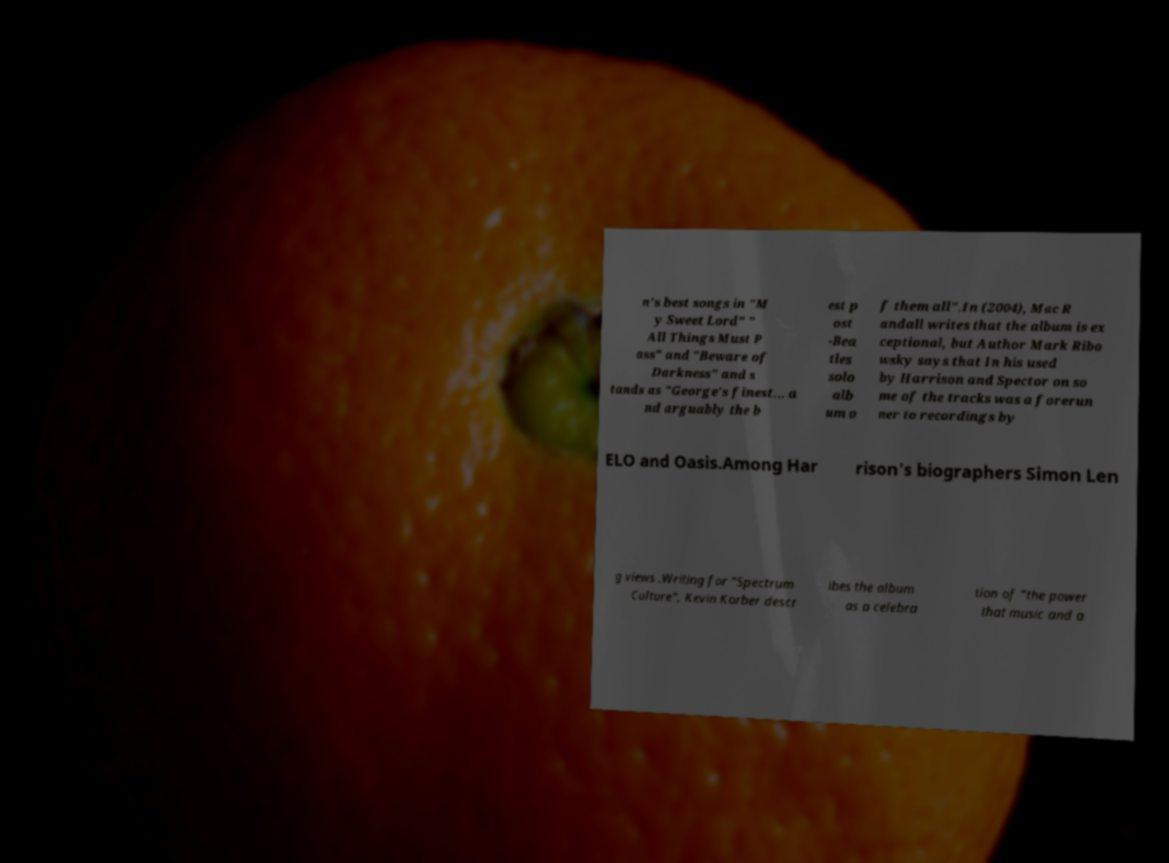Could you assist in decoding the text presented in this image and type it out clearly? n's best songs in "M y Sweet Lord" " All Things Must P ass" and "Beware of Darkness" and s tands as "George's finest... a nd arguably the b est p ost -Bea tles solo alb um o f them all".In (2004), Mac R andall writes that the album is ex ceptional, but Author Mark Ribo wsky says that In his used by Harrison and Spector on so me of the tracks was a forerun ner to recordings by ELO and Oasis.Among Har rison's biographers Simon Len g views .Writing for "Spectrum Culture", Kevin Korber descr ibes the album as a celebra tion of "the power that music and a 